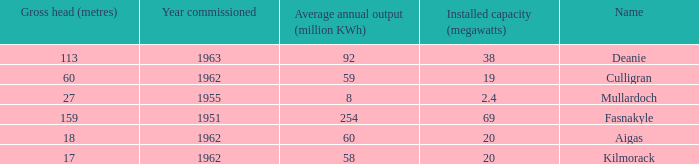What is the earliest Year commissioned wiht an Average annual output greater than 58 and Installed capacity of 20? 1962.0. 